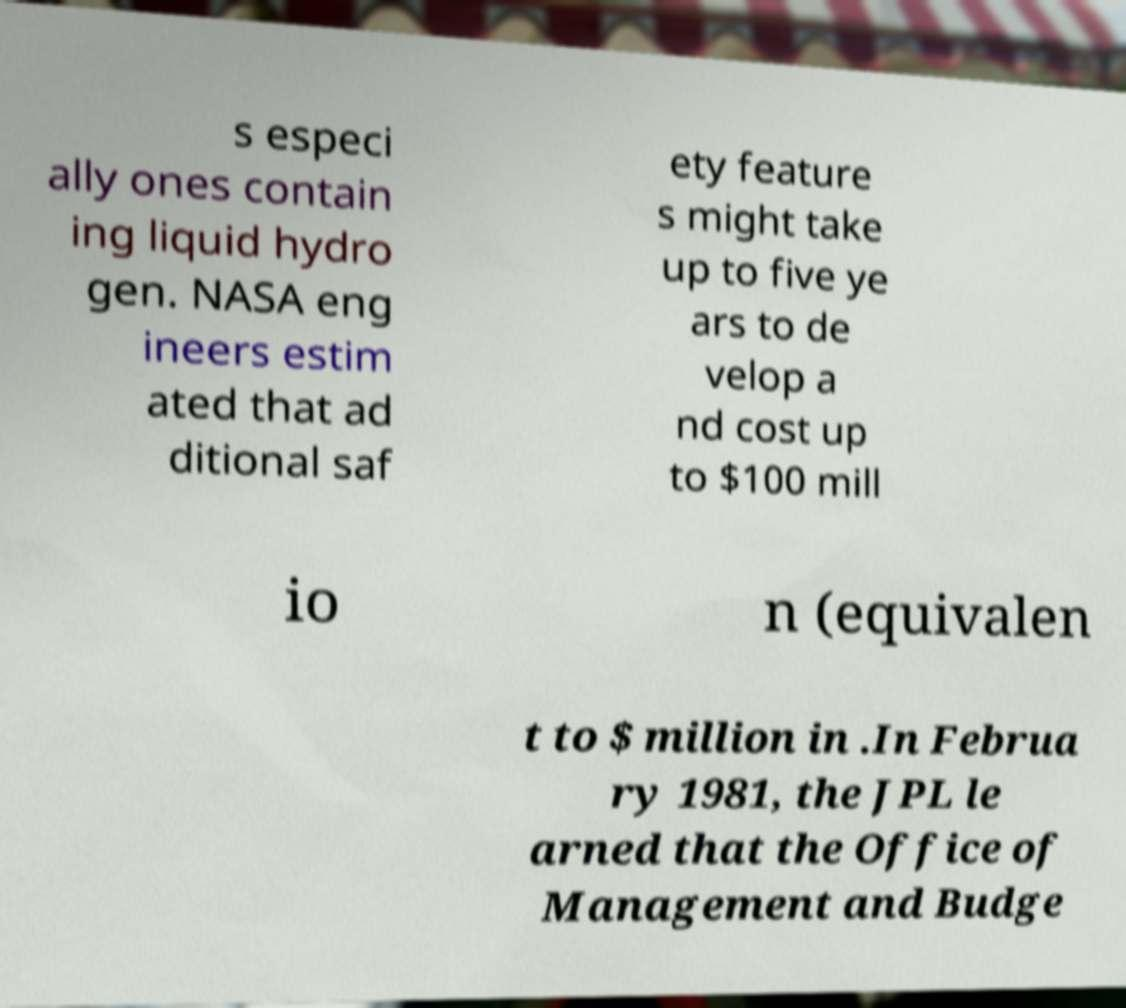Can you accurately transcribe the text from the provided image for me? s especi ally ones contain ing liquid hydro gen. NASA eng ineers estim ated that ad ditional saf ety feature s might take up to five ye ars to de velop a nd cost up to $100 mill io n (equivalen t to $ million in .In Februa ry 1981, the JPL le arned that the Office of Management and Budge 